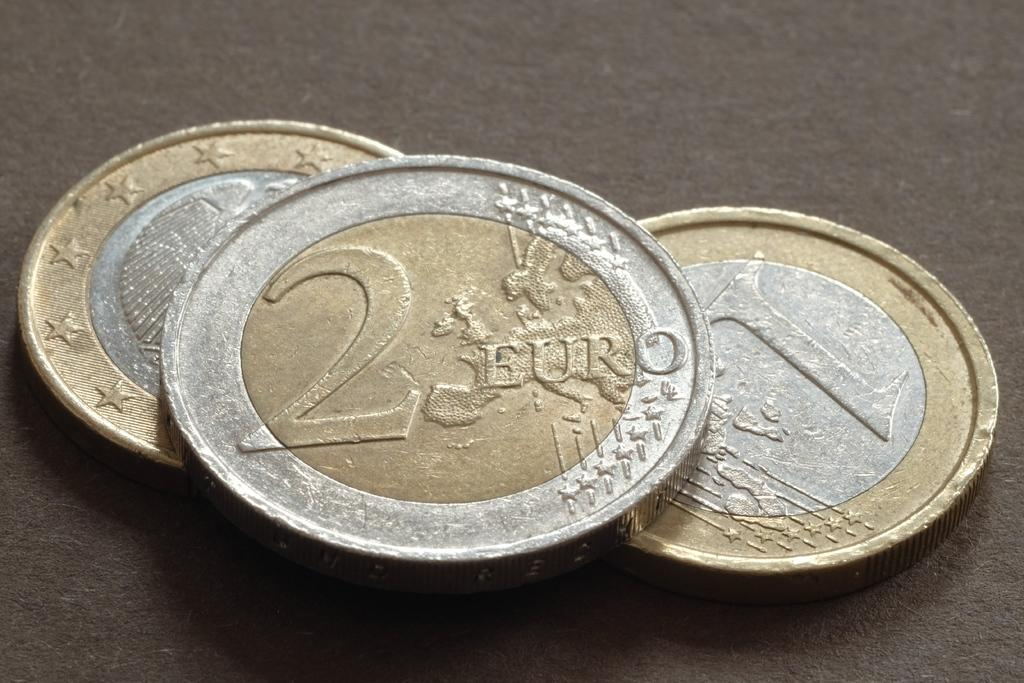Provide a one-sentence caption for the provided image. Silver and gold coins with 2 EURO printed on the top coin. 